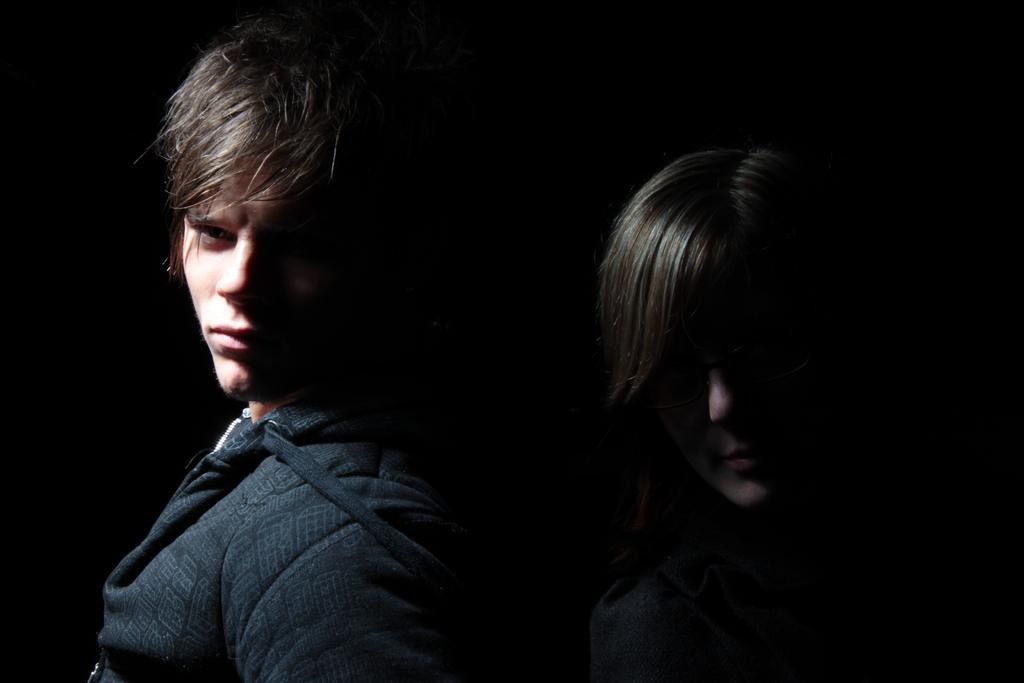Could you give a brief overview of what you see in this image? As we can see in the image there are two people. The man on the left side is wearing black color jacket. The image is little dark. 